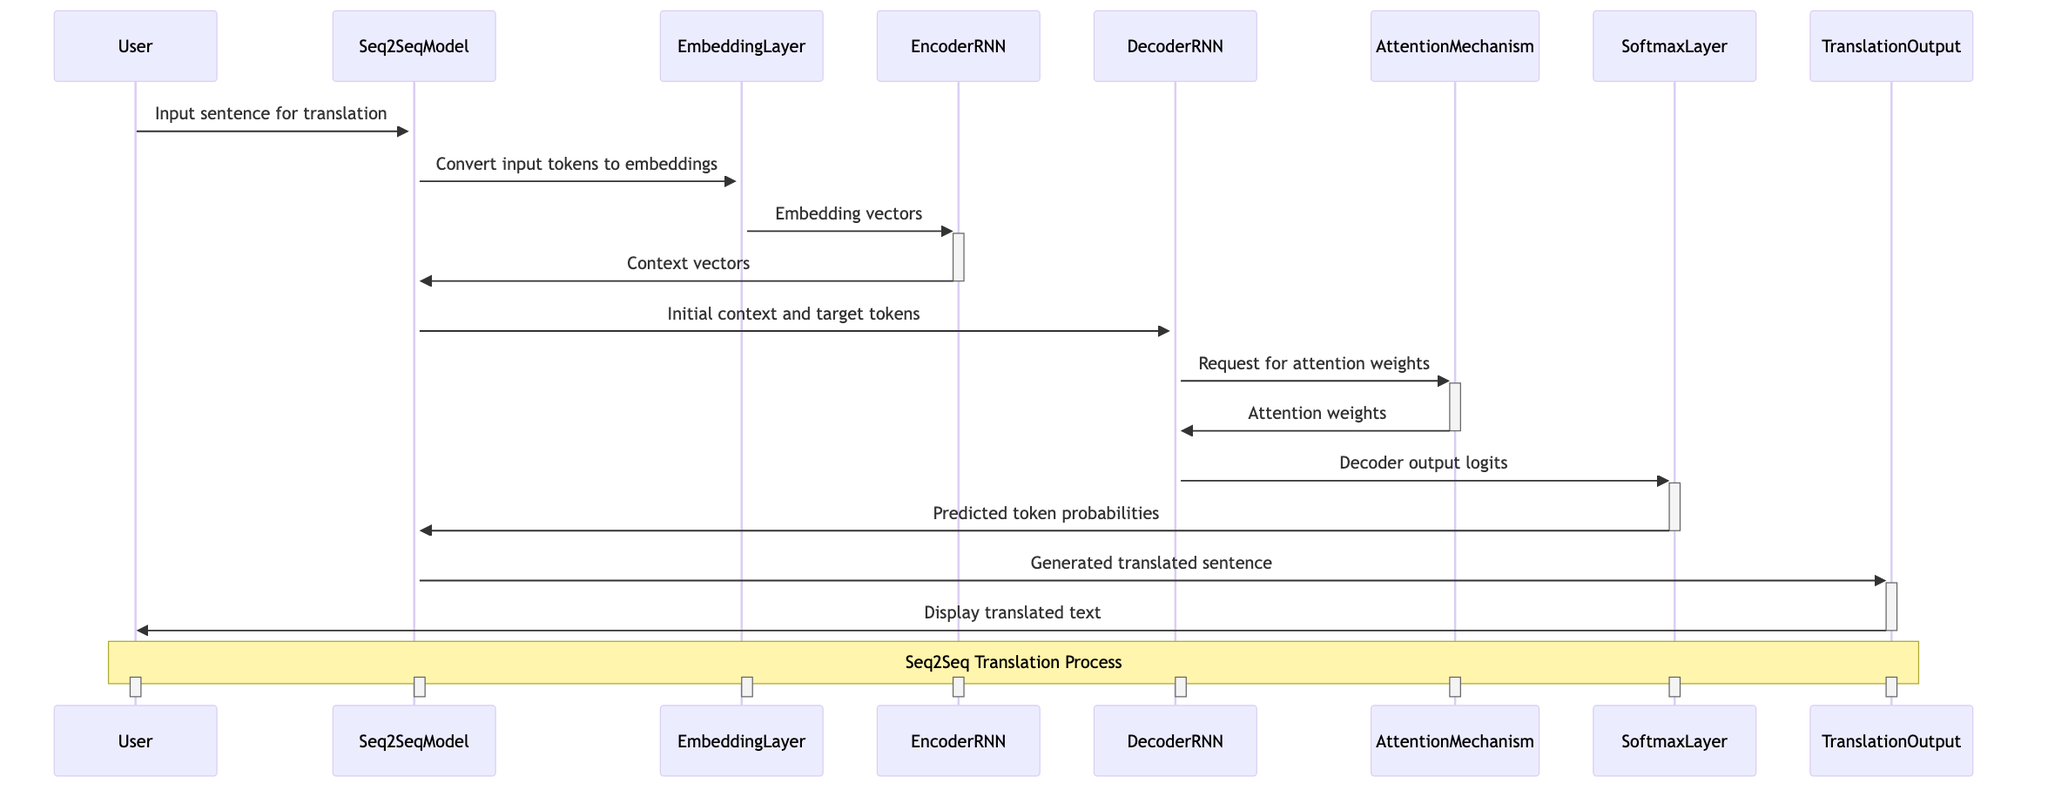What is the role of the User in this sequence diagram? The User provides input for translation to the Seq2Seq Model. This can be seen as the User is the initiating actor in the sequence, starting the interaction by sending an input sentence for translation.
Answer: Provides input for translation How many main components (actors) are present in the diagram? By counting the distinct participants listed in the diagram, we find there are eight actors: User, Seq2SeqModel, EmbeddingLayer, EncoderRNN, DecoderRNN, AttentionMechanism, SoftmaxLayer, and TranslationOutput.
Answer: Eight What message does the Seq2SeqModel send to the EmbeddingLayer? According to the diagram, the Seq2SeqModel sends the message "Convert input tokens to embeddings" to the EmbeddingLayer, indicating the action it requires from this component.
Answer: Convert input tokens to embeddings Which component generates the predicted token probabilities? Tracing the flow of messages, the SoftmaxLayer receives the decoder output logits from the DecoderRNN and generates the probabilities for each token in the target vocabulary. Therefore, the SoftmaxLayer is responsible for this action.
Answer: SoftmaxLayer What type of mechanism is used to calculate attention weights? The AttentionMechanism is specifically referenced in the diagram as handling the request for attention weights, which is a critical part of ensuring the DecoderRNN can focus on relevant parts of the encoded input sequence.
Answer: AttentionMechanism How does the DecoderRNN get the attention weights? The DecoderRNN requests the attention weights from the AttentionMechanism, which then responds with the appropriate attention weights, allowing the DecoderRNN to utilize them during the decoding process.
Answer: By requesting from AttentionMechanism What is the final action taken by the TranslationOutput? The TranslationOutput's final action, as indicated in the diagram, is to display the translated text to the User. This shows the culmination of the translation process initiated by the User's input.
Answer: Display translated text What is the first interaction in the sequence diagram? The first interaction comes from the User sending the input sentence for translation to the Seq2SeqModel, highlighting the user's role as the starting point of the entire translation process.
Answer: Input sentence for translation How many total messages are exchanged in the diagram? By counting the interactions listed under messages, we see that there are a total of eleven messages exchanged between the various actors throughout the translation process.
Answer: Eleven 